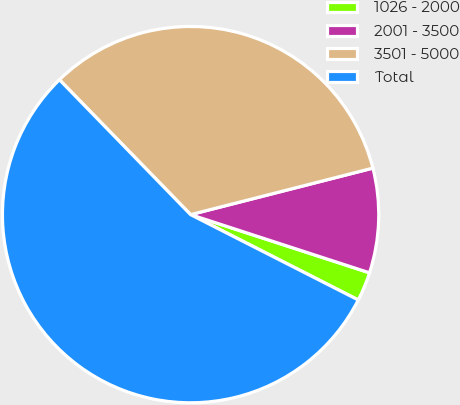Convert chart. <chart><loc_0><loc_0><loc_500><loc_500><pie_chart><fcel>1026 - 2000<fcel>2001 - 3500<fcel>3501 - 5000<fcel>Total<nl><fcel>2.49%<fcel>8.98%<fcel>33.3%<fcel>55.23%<nl></chart> 